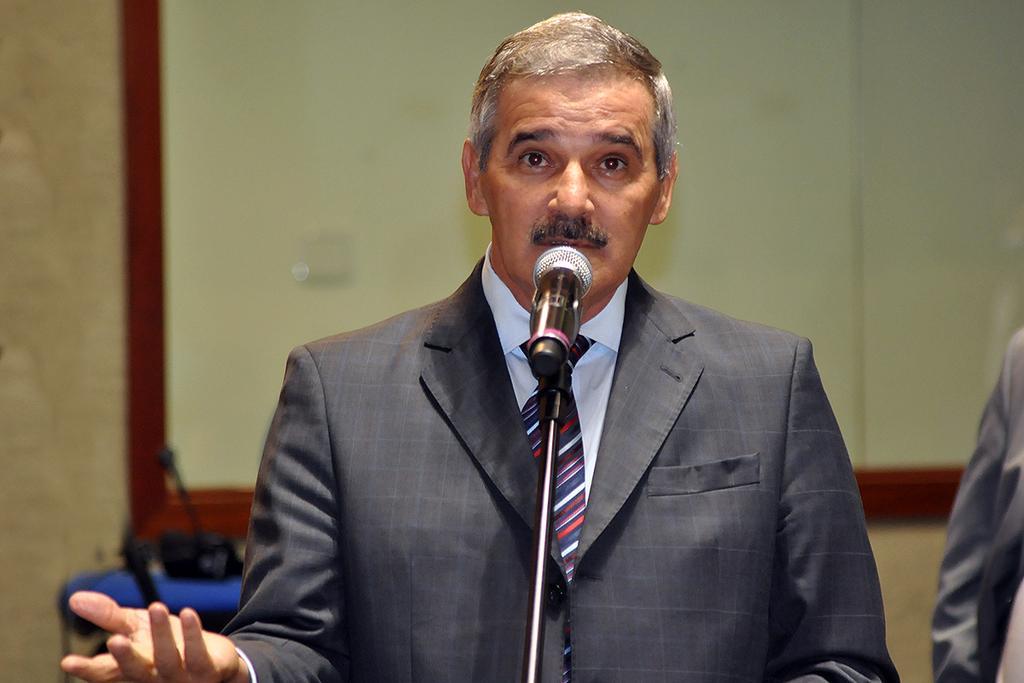In one or two sentences, can you explain what this image depicts? In this image we can see a person wearing a coat and a tie is standing in front of a microphone placed on a stand. In the background we can see a board and a person. 